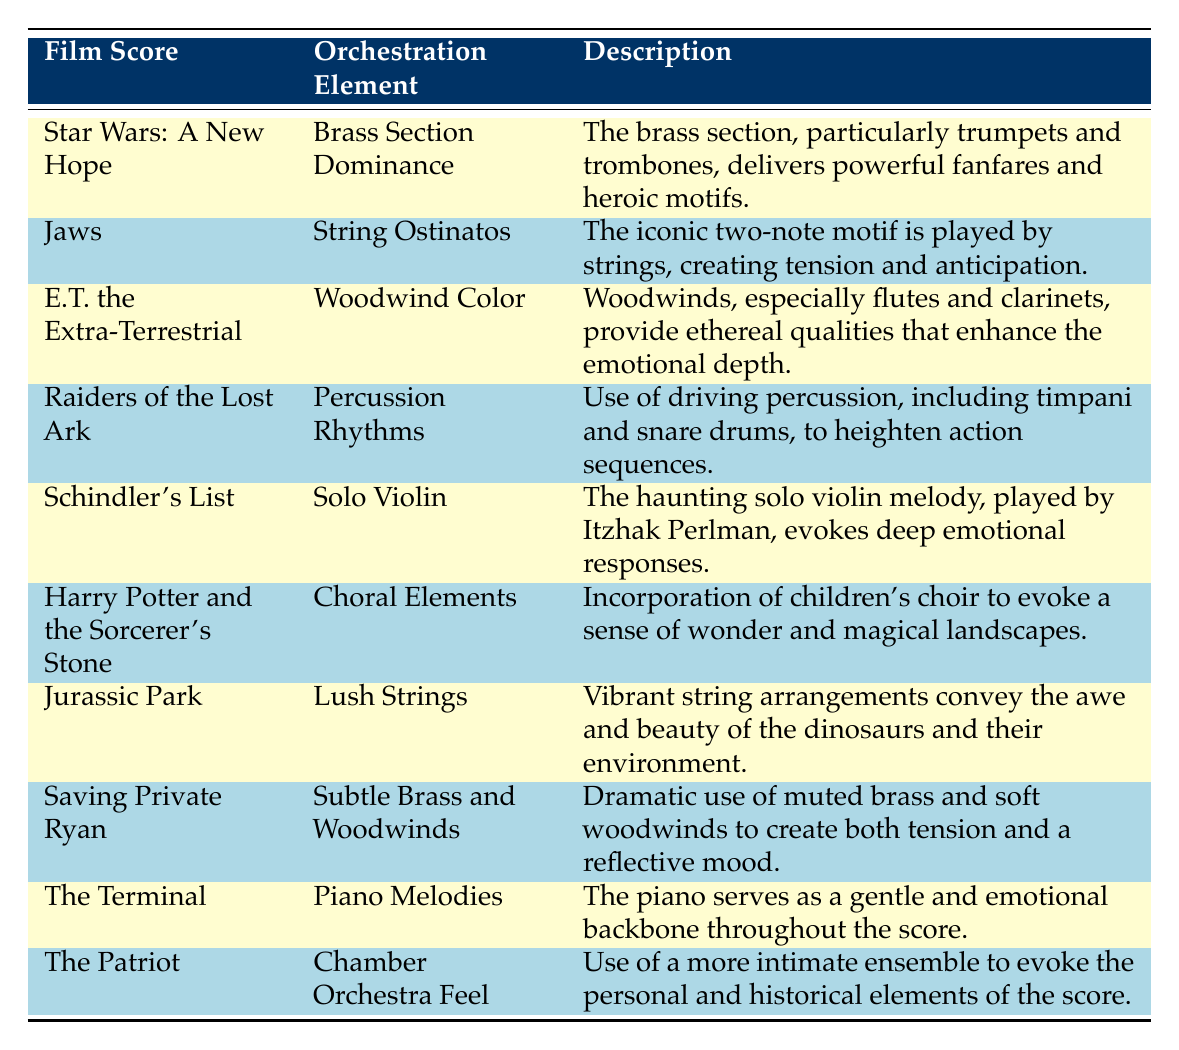What orchestration element is associated with the film score "Jaws"? The table lists "String Ostinatos" as the orchestration element for "Jaws".
Answer: String Ostinatos Which film score features "Lush Strings" as an orchestration element? According to the table, "Lush Strings" is associated with "Jurassic Park".
Answer: Jurassic Park Does "Star Wars: A New Hope" utilize a "Chamber Orchestra Feel"? The table indicates that "Star Wars: A New Hope" does not feature "Chamber Orchestra Feel"; instead, this element is associated with "The Patriot".
Answer: No What is the orchestration element that enhances emotional depth in "E.T. the Extra-Terrestrial"? The table states that "Woodwind Color" is the orchestration element that enhances emotional depth in "E.T. the Extra-Terrestrial".
Answer: Woodwind Color Which film score has a specific orchestration element played by Itzhak Perlman? The table reveals that "Schindler's List" features a "Solo Violin", which is played by Itzhak Perlman.
Answer: Schindler's List Which film scores use the brass section in comparison to woodwinds? What are the orchestration elements for both? "Star Wars: A New Hope" uses "Brass Section Dominance," and "Saving Private Ryan" uses "Subtle Brass and Woodwinds". Both scores utilize brass but focus on different orchestration techniques.
Answer: Star Wars: A New Hope - Brass Section Dominance; Saving Private Ryan - Subtle Brass and Woodwinds How many film scores listed on the table incorporate choral elements? The table mentions that "Harry Potter and the Sorcerer's Stone" incorporates choral elements. Thus, there is only one film score with this feature.
Answer: 1 What are the two orchestration elements found in "The Terminal"? The table identifies "Piano Melodies" as the only orchestration element listed for "The Terminal".
Answer: Piano Melodies Which orchestration element evokes a sense of wonder and magical landscapes? According to the table, "Choral Elements" in "Harry Potter and the Sorcerer's Stone" evokes this sense of wonder.
Answer: Choral Elements 